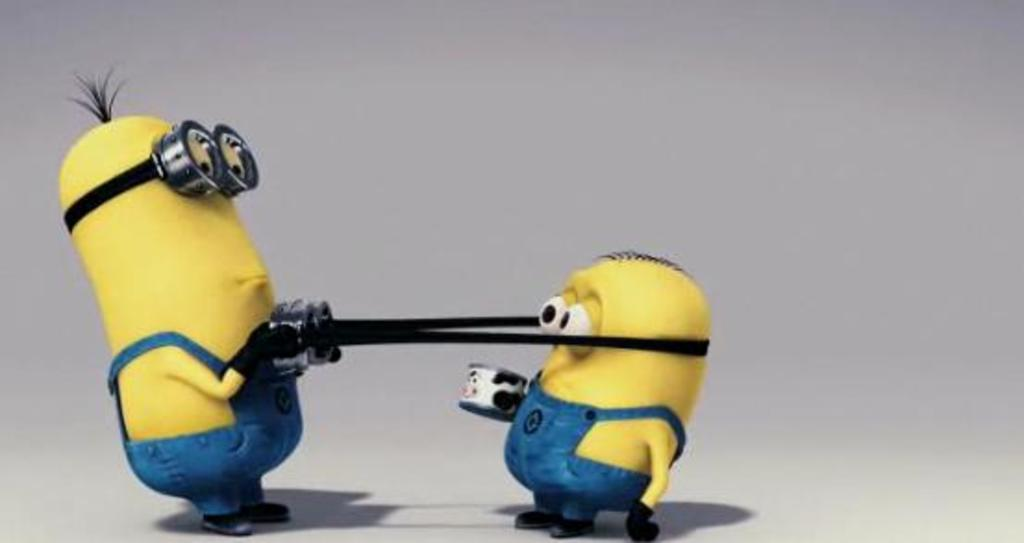What characters are featured in the picture? There are minions in the picture. What color is the background of the picture? The background of the picture is white. What is the price of the minions in the picture? The picture is not a product, so there is no price associated with the minions. How many toes do the minions have in the picture? The picture does not show the minions' feet, so it is impossible to determine the number of toes they have. 